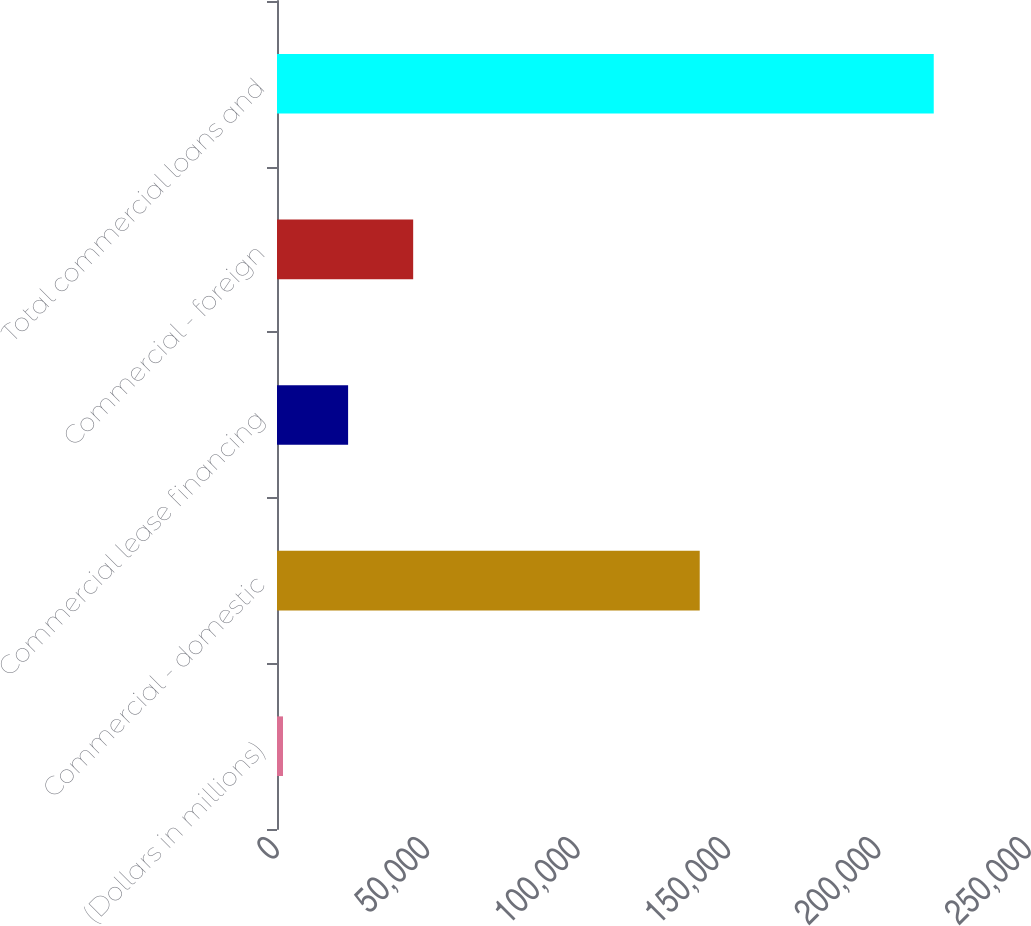Convert chart. <chart><loc_0><loc_0><loc_500><loc_500><bar_chart><fcel>(Dollars in millions)<fcel>Commercial - domestic<fcel>Commercial lease financing<fcel>Commercial - foreign<fcel>Total commercial loans and<nl><fcel>2005<fcel>140533<fcel>23637.9<fcel>45270.8<fcel>218334<nl></chart> 